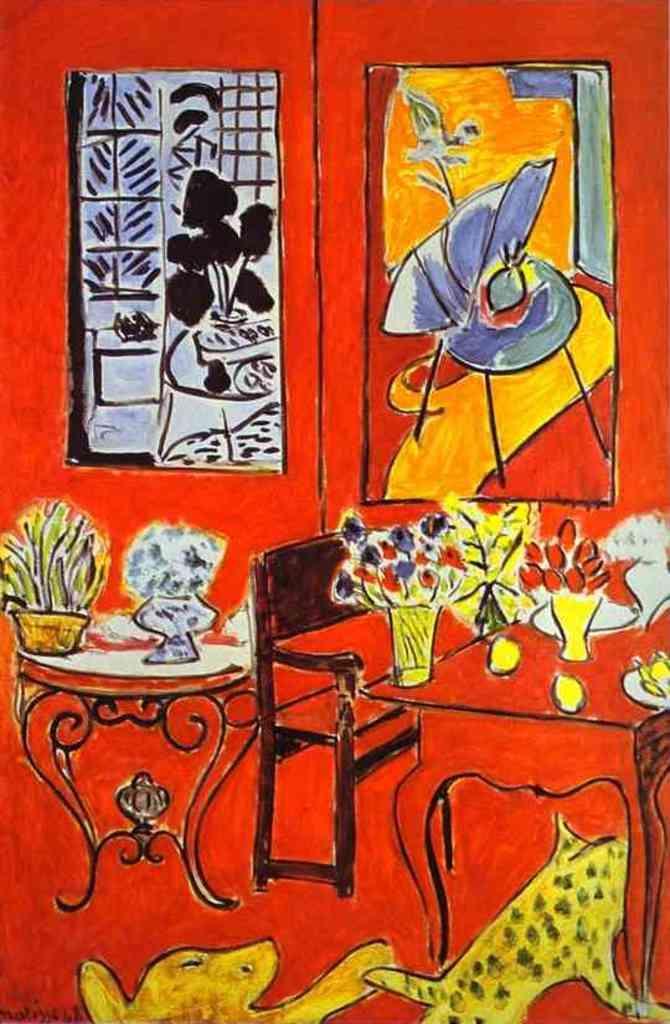Can you describe this image briefly? In this image we can see painting of tables, vases with flowers, bench, animals and photo frames on the wall. 